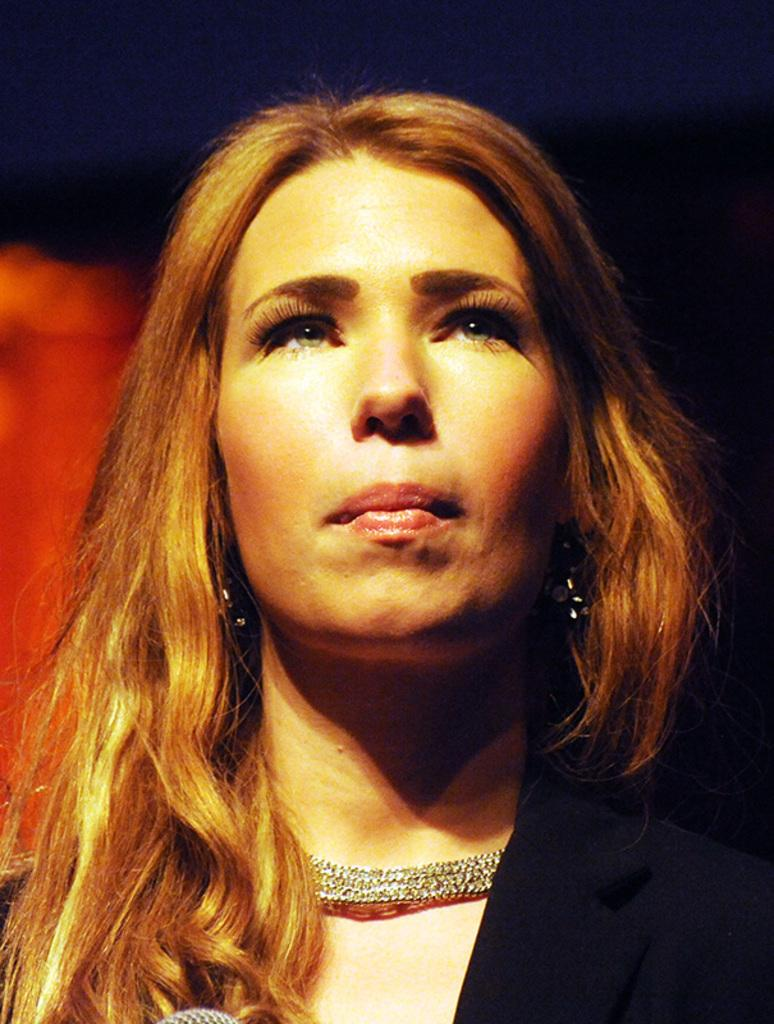Who is the main subject in the image? There is a woman in the image. What is the woman wearing in the image? The woman is wearing a necklace in the image. Can you describe the background of the image? The background of the image is blurry. What type of fish can be seen swimming in the background of the image? There are no fish present in the image; the background is blurry. 